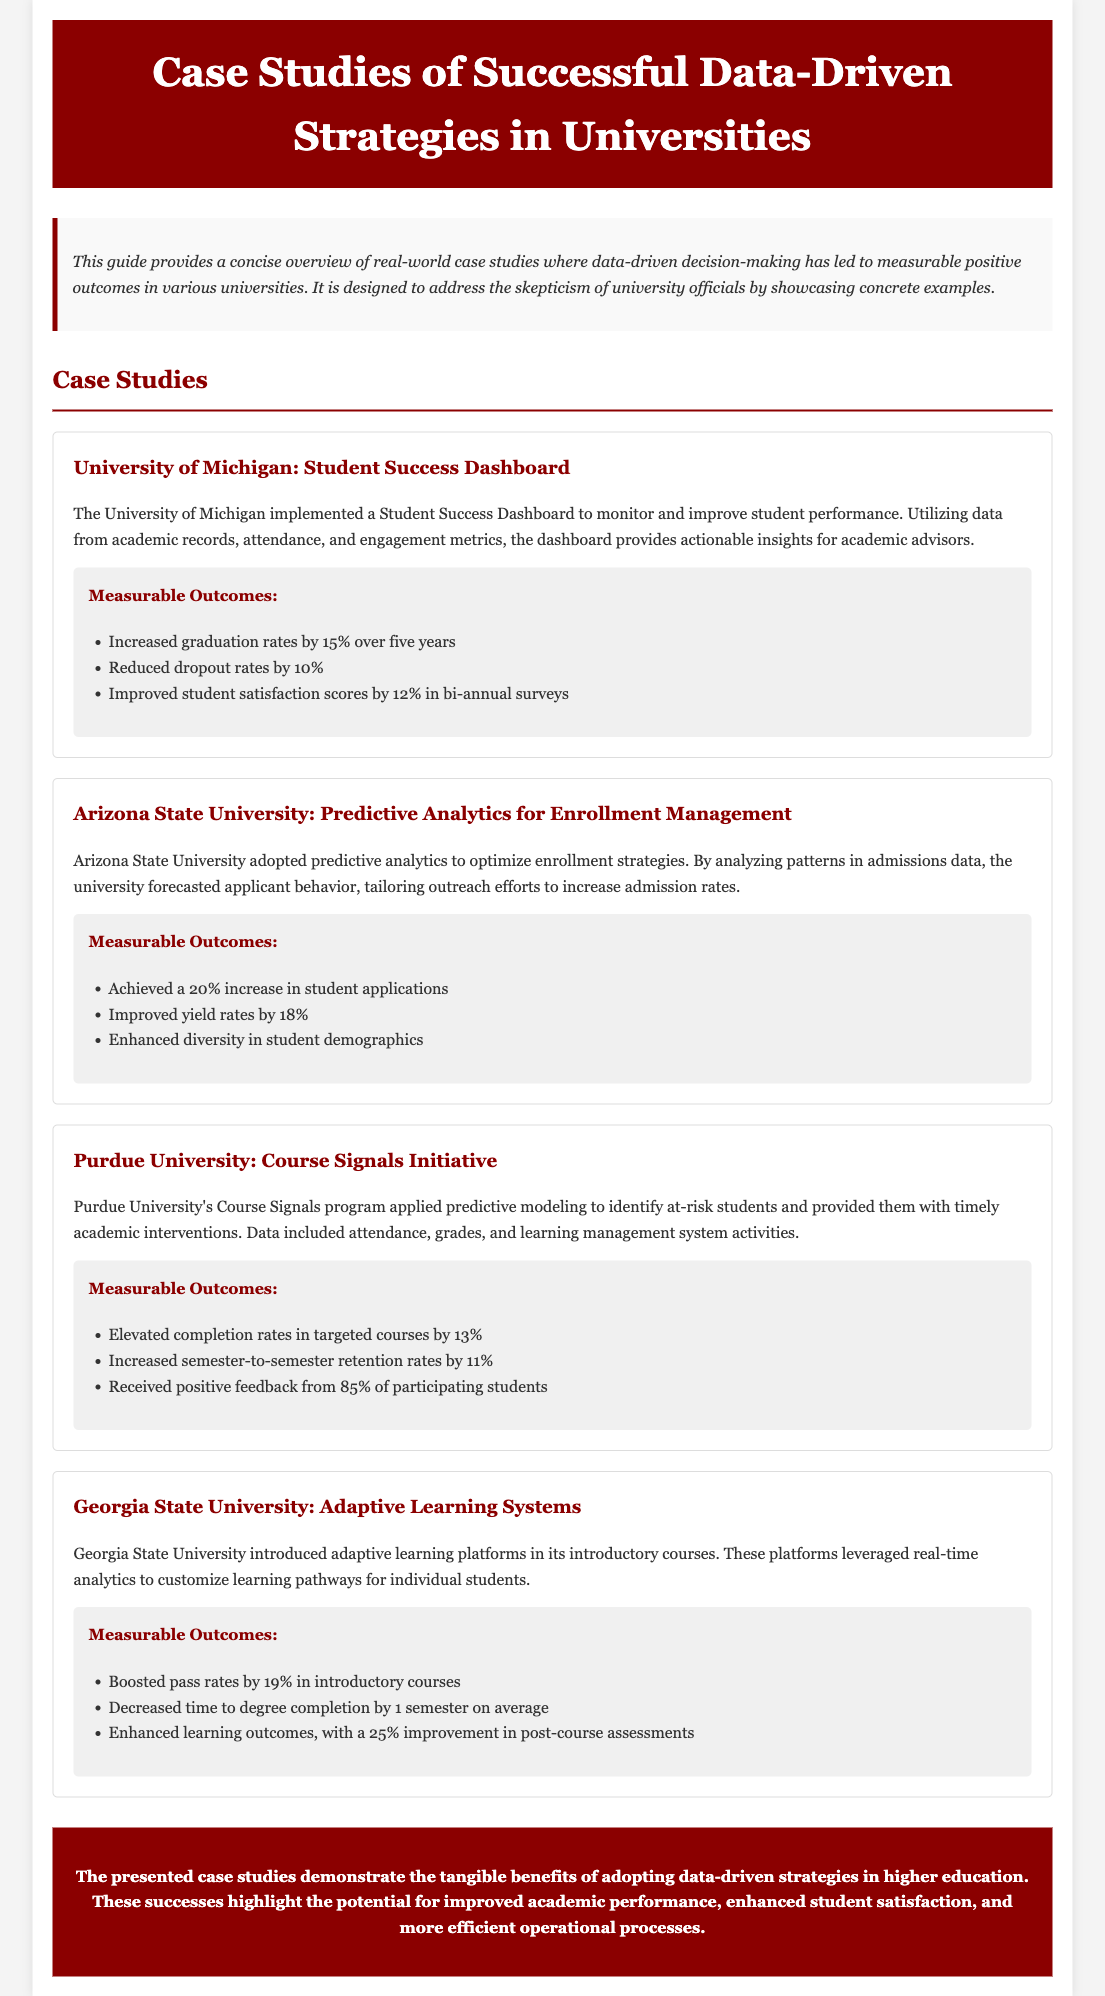what is the title of the document? The title of the document is prominently displayed in the header section.
Answer: Case Studies of Successful Data-Driven Strategies in Universities which university implemented a Student Success Dashboard? The document mentions the specific university in the case study details.
Answer: University of Michigan what percentage increase in graduation rates did the University of Michigan achieve? This information is found in the measurable outcomes noted for that case study.
Answer: 15% how much did Arizona State University improve yield rates? The document provides a specific metric related to enrollment management strategies.
Answer: 18% what initiative did Purdue University introduce for identifying at-risk students? This detail is highlighted in the description of Purdue University's efforts.
Answer: Course Signals Initiative which university used adaptive learning platforms? The document specifies the university that implemented this particular strategy.
Answer: Georgia State University how much did Georgia State University boost pass rates by? The measurable outcome is listed in the section describing the university's initiative.
Answer: 19% which metric improved by 25% in Georgia State University’s initiative? The document outlines this improvement in learning outcomes specifically.
Answer: post-course assessments what was the general sentiment from students participating in Purdue University's initiative? The document reports an overall positive feedback metric for that case.
Answer: 85% 